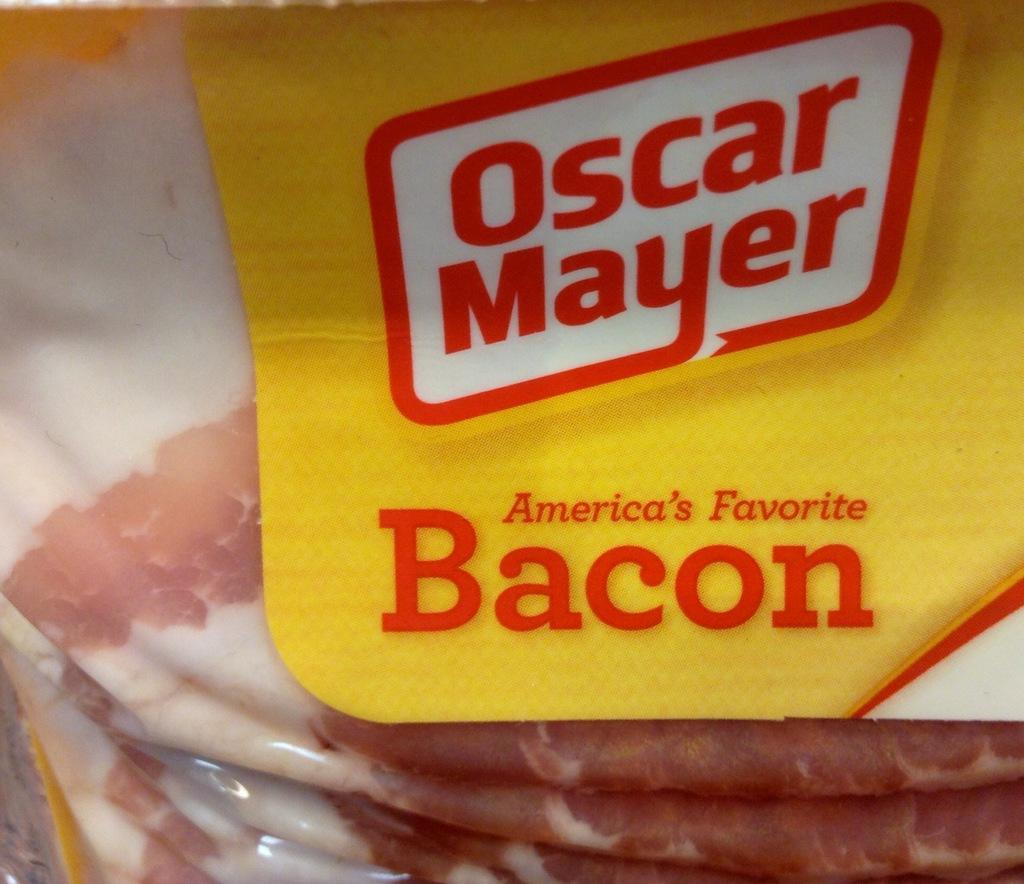How would you summarize this image in a sentence or two? In this image, I can see meat items in a packet. This image is taken, maybe in a shop. 